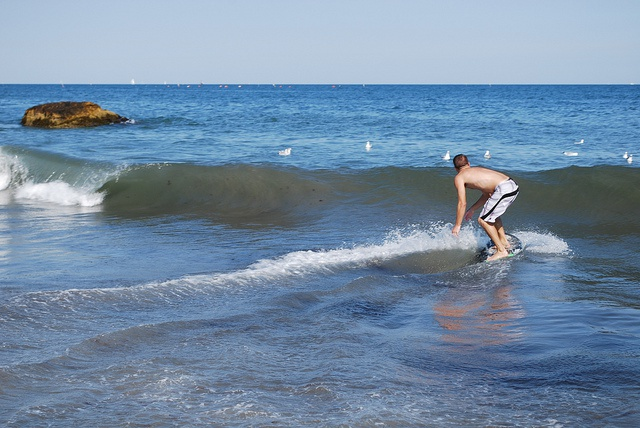Describe the objects in this image and their specific colors. I can see people in lightblue, lightgray, tan, and gray tones, surfboard in lightblue, darkgray, gray, and lightgray tones, bird in lightblue, gray, lightgray, and darkgray tones, bird in lightblue, lightgray, gray, and darkgray tones, and bird in lightblue and lightgray tones in this image. 